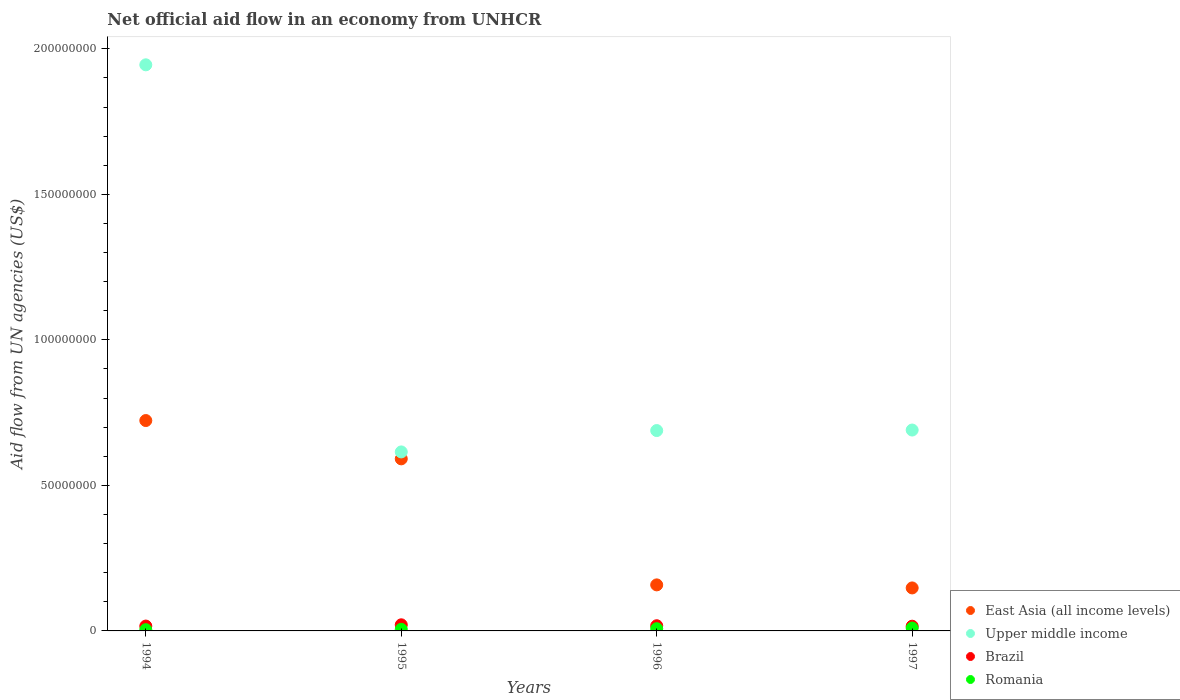Is the number of dotlines equal to the number of legend labels?
Your response must be concise. Yes. What is the net official aid flow in Brazil in 1997?
Your response must be concise. 1.62e+06. Across all years, what is the maximum net official aid flow in Upper middle income?
Provide a succinct answer. 1.94e+08. Across all years, what is the minimum net official aid flow in Brazil?
Provide a succinct answer. 1.62e+06. What is the total net official aid flow in Brazil in the graph?
Provide a succinct answer. 7.17e+06. What is the difference between the net official aid flow in Brazil in 1995 and that in 1996?
Ensure brevity in your answer.  3.20e+05. What is the difference between the net official aid flow in Romania in 1997 and the net official aid flow in Brazil in 1996?
Make the answer very short. -7.90e+05. What is the average net official aid flow in Brazil per year?
Provide a short and direct response. 1.79e+06. In the year 1997, what is the difference between the net official aid flow in Brazil and net official aid flow in Upper middle income?
Make the answer very short. -6.74e+07. In how many years, is the net official aid flow in Upper middle income greater than 140000000 US$?
Make the answer very short. 1. What is the ratio of the net official aid flow in Brazil in 1994 to that in 1996?
Provide a succinct answer. 0.94. What is the difference between the highest and the second highest net official aid flow in Romania?
Give a very brief answer. 2.30e+05. What is the difference between the highest and the lowest net official aid flow in Romania?
Your answer should be compact. 5.60e+05. Is it the case that in every year, the sum of the net official aid flow in Brazil and net official aid flow in Upper middle income  is greater than the sum of net official aid flow in East Asia (all income levels) and net official aid flow in Romania?
Provide a short and direct response. No. Is it the case that in every year, the sum of the net official aid flow in Brazil and net official aid flow in Romania  is greater than the net official aid flow in Upper middle income?
Provide a succinct answer. No. Is the net official aid flow in East Asia (all income levels) strictly less than the net official aid flow in Upper middle income over the years?
Ensure brevity in your answer.  Yes. How many years are there in the graph?
Your answer should be compact. 4. What is the difference between two consecutive major ticks on the Y-axis?
Provide a succinct answer. 5.00e+07. How many legend labels are there?
Offer a very short reply. 4. What is the title of the graph?
Provide a succinct answer. Net official aid flow in an economy from UNHCR. What is the label or title of the X-axis?
Keep it short and to the point. Years. What is the label or title of the Y-axis?
Provide a short and direct response. Aid flow from UN agencies (US$). What is the Aid flow from UN agencies (US$) of East Asia (all income levels) in 1994?
Ensure brevity in your answer.  7.23e+07. What is the Aid flow from UN agencies (US$) in Upper middle income in 1994?
Ensure brevity in your answer.  1.94e+08. What is the Aid flow from UN agencies (US$) in Brazil in 1994?
Provide a succinct answer. 1.67e+06. What is the Aid flow from UN agencies (US$) of East Asia (all income levels) in 1995?
Ensure brevity in your answer.  5.91e+07. What is the Aid flow from UN agencies (US$) of Upper middle income in 1995?
Offer a very short reply. 6.15e+07. What is the Aid flow from UN agencies (US$) of Brazil in 1995?
Give a very brief answer. 2.10e+06. What is the Aid flow from UN agencies (US$) of Romania in 1995?
Offer a very short reply. 5.50e+05. What is the Aid flow from UN agencies (US$) in East Asia (all income levels) in 1996?
Offer a very short reply. 1.58e+07. What is the Aid flow from UN agencies (US$) of Upper middle income in 1996?
Ensure brevity in your answer.  6.88e+07. What is the Aid flow from UN agencies (US$) of Brazil in 1996?
Your response must be concise. 1.78e+06. What is the Aid flow from UN agencies (US$) of Romania in 1996?
Your answer should be compact. 7.60e+05. What is the Aid flow from UN agencies (US$) in East Asia (all income levels) in 1997?
Give a very brief answer. 1.48e+07. What is the Aid flow from UN agencies (US$) of Upper middle income in 1997?
Provide a short and direct response. 6.90e+07. What is the Aid flow from UN agencies (US$) of Brazil in 1997?
Your response must be concise. 1.62e+06. What is the Aid flow from UN agencies (US$) of Romania in 1997?
Provide a short and direct response. 9.90e+05. Across all years, what is the maximum Aid flow from UN agencies (US$) in East Asia (all income levels)?
Your answer should be compact. 7.23e+07. Across all years, what is the maximum Aid flow from UN agencies (US$) in Upper middle income?
Provide a succinct answer. 1.94e+08. Across all years, what is the maximum Aid flow from UN agencies (US$) of Brazil?
Your answer should be very brief. 2.10e+06. Across all years, what is the maximum Aid flow from UN agencies (US$) in Romania?
Provide a short and direct response. 9.90e+05. Across all years, what is the minimum Aid flow from UN agencies (US$) in East Asia (all income levels)?
Make the answer very short. 1.48e+07. Across all years, what is the minimum Aid flow from UN agencies (US$) of Upper middle income?
Provide a short and direct response. 6.15e+07. Across all years, what is the minimum Aid flow from UN agencies (US$) in Brazil?
Offer a very short reply. 1.62e+06. What is the total Aid flow from UN agencies (US$) of East Asia (all income levels) in the graph?
Your answer should be compact. 1.62e+08. What is the total Aid flow from UN agencies (US$) in Upper middle income in the graph?
Make the answer very short. 3.94e+08. What is the total Aid flow from UN agencies (US$) in Brazil in the graph?
Your response must be concise. 7.17e+06. What is the total Aid flow from UN agencies (US$) in Romania in the graph?
Your response must be concise. 2.73e+06. What is the difference between the Aid flow from UN agencies (US$) of East Asia (all income levels) in 1994 and that in 1995?
Offer a very short reply. 1.32e+07. What is the difference between the Aid flow from UN agencies (US$) in Upper middle income in 1994 and that in 1995?
Your answer should be very brief. 1.33e+08. What is the difference between the Aid flow from UN agencies (US$) in Brazil in 1994 and that in 1995?
Provide a succinct answer. -4.30e+05. What is the difference between the Aid flow from UN agencies (US$) in Romania in 1994 and that in 1995?
Provide a succinct answer. -1.20e+05. What is the difference between the Aid flow from UN agencies (US$) in East Asia (all income levels) in 1994 and that in 1996?
Give a very brief answer. 5.65e+07. What is the difference between the Aid flow from UN agencies (US$) in Upper middle income in 1994 and that in 1996?
Make the answer very short. 1.26e+08. What is the difference between the Aid flow from UN agencies (US$) of Romania in 1994 and that in 1996?
Make the answer very short. -3.30e+05. What is the difference between the Aid flow from UN agencies (US$) in East Asia (all income levels) in 1994 and that in 1997?
Ensure brevity in your answer.  5.75e+07. What is the difference between the Aid flow from UN agencies (US$) in Upper middle income in 1994 and that in 1997?
Your answer should be compact. 1.25e+08. What is the difference between the Aid flow from UN agencies (US$) of Brazil in 1994 and that in 1997?
Offer a very short reply. 5.00e+04. What is the difference between the Aid flow from UN agencies (US$) of Romania in 1994 and that in 1997?
Offer a terse response. -5.60e+05. What is the difference between the Aid flow from UN agencies (US$) of East Asia (all income levels) in 1995 and that in 1996?
Your answer should be compact. 4.33e+07. What is the difference between the Aid flow from UN agencies (US$) in Upper middle income in 1995 and that in 1996?
Your answer should be very brief. -7.34e+06. What is the difference between the Aid flow from UN agencies (US$) in Brazil in 1995 and that in 1996?
Provide a succinct answer. 3.20e+05. What is the difference between the Aid flow from UN agencies (US$) in Romania in 1995 and that in 1996?
Give a very brief answer. -2.10e+05. What is the difference between the Aid flow from UN agencies (US$) of East Asia (all income levels) in 1995 and that in 1997?
Ensure brevity in your answer.  4.44e+07. What is the difference between the Aid flow from UN agencies (US$) of Upper middle income in 1995 and that in 1997?
Ensure brevity in your answer.  -7.52e+06. What is the difference between the Aid flow from UN agencies (US$) in Brazil in 1995 and that in 1997?
Make the answer very short. 4.80e+05. What is the difference between the Aid flow from UN agencies (US$) in Romania in 1995 and that in 1997?
Your answer should be compact. -4.40e+05. What is the difference between the Aid flow from UN agencies (US$) of East Asia (all income levels) in 1996 and that in 1997?
Provide a short and direct response. 1.05e+06. What is the difference between the Aid flow from UN agencies (US$) in Romania in 1996 and that in 1997?
Offer a terse response. -2.30e+05. What is the difference between the Aid flow from UN agencies (US$) of East Asia (all income levels) in 1994 and the Aid flow from UN agencies (US$) of Upper middle income in 1995?
Offer a very short reply. 1.08e+07. What is the difference between the Aid flow from UN agencies (US$) of East Asia (all income levels) in 1994 and the Aid flow from UN agencies (US$) of Brazil in 1995?
Make the answer very short. 7.02e+07. What is the difference between the Aid flow from UN agencies (US$) of East Asia (all income levels) in 1994 and the Aid flow from UN agencies (US$) of Romania in 1995?
Your answer should be very brief. 7.17e+07. What is the difference between the Aid flow from UN agencies (US$) of Upper middle income in 1994 and the Aid flow from UN agencies (US$) of Brazil in 1995?
Offer a terse response. 1.92e+08. What is the difference between the Aid flow from UN agencies (US$) of Upper middle income in 1994 and the Aid flow from UN agencies (US$) of Romania in 1995?
Make the answer very short. 1.94e+08. What is the difference between the Aid flow from UN agencies (US$) of Brazil in 1994 and the Aid flow from UN agencies (US$) of Romania in 1995?
Your answer should be compact. 1.12e+06. What is the difference between the Aid flow from UN agencies (US$) of East Asia (all income levels) in 1994 and the Aid flow from UN agencies (US$) of Upper middle income in 1996?
Your answer should be very brief. 3.44e+06. What is the difference between the Aid flow from UN agencies (US$) in East Asia (all income levels) in 1994 and the Aid flow from UN agencies (US$) in Brazil in 1996?
Give a very brief answer. 7.05e+07. What is the difference between the Aid flow from UN agencies (US$) in East Asia (all income levels) in 1994 and the Aid flow from UN agencies (US$) in Romania in 1996?
Your answer should be very brief. 7.15e+07. What is the difference between the Aid flow from UN agencies (US$) in Upper middle income in 1994 and the Aid flow from UN agencies (US$) in Brazil in 1996?
Ensure brevity in your answer.  1.93e+08. What is the difference between the Aid flow from UN agencies (US$) in Upper middle income in 1994 and the Aid flow from UN agencies (US$) in Romania in 1996?
Offer a terse response. 1.94e+08. What is the difference between the Aid flow from UN agencies (US$) in Brazil in 1994 and the Aid flow from UN agencies (US$) in Romania in 1996?
Your answer should be compact. 9.10e+05. What is the difference between the Aid flow from UN agencies (US$) in East Asia (all income levels) in 1994 and the Aid flow from UN agencies (US$) in Upper middle income in 1997?
Give a very brief answer. 3.26e+06. What is the difference between the Aid flow from UN agencies (US$) in East Asia (all income levels) in 1994 and the Aid flow from UN agencies (US$) in Brazil in 1997?
Offer a very short reply. 7.07e+07. What is the difference between the Aid flow from UN agencies (US$) of East Asia (all income levels) in 1994 and the Aid flow from UN agencies (US$) of Romania in 1997?
Make the answer very short. 7.13e+07. What is the difference between the Aid flow from UN agencies (US$) in Upper middle income in 1994 and the Aid flow from UN agencies (US$) in Brazil in 1997?
Give a very brief answer. 1.93e+08. What is the difference between the Aid flow from UN agencies (US$) of Upper middle income in 1994 and the Aid flow from UN agencies (US$) of Romania in 1997?
Provide a short and direct response. 1.94e+08. What is the difference between the Aid flow from UN agencies (US$) in Brazil in 1994 and the Aid flow from UN agencies (US$) in Romania in 1997?
Provide a short and direct response. 6.80e+05. What is the difference between the Aid flow from UN agencies (US$) of East Asia (all income levels) in 1995 and the Aid flow from UN agencies (US$) of Upper middle income in 1996?
Keep it short and to the point. -9.72e+06. What is the difference between the Aid flow from UN agencies (US$) in East Asia (all income levels) in 1995 and the Aid flow from UN agencies (US$) in Brazil in 1996?
Ensure brevity in your answer.  5.73e+07. What is the difference between the Aid flow from UN agencies (US$) in East Asia (all income levels) in 1995 and the Aid flow from UN agencies (US$) in Romania in 1996?
Offer a terse response. 5.84e+07. What is the difference between the Aid flow from UN agencies (US$) in Upper middle income in 1995 and the Aid flow from UN agencies (US$) in Brazil in 1996?
Make the answer very short. 5.97e+07. What is the difference between the Aid flow from UN agencies (US$) in Upper middle income in 1995 and the Aid flow from UN agencies (US$) in Romania in 1996?
Make the answer very short. 6.07e+07. What is the difference between the Aid flow from UN agencies (US$) in Brazil in 1995 and the Aid flow from UN agencies (US$) in Romania in 1996?
Offer a terse response. 1.34e+06. What is the difference between the Aid flow from UN agencies (US$) in East Asia (all income levels) in 1995 and the Aid flow from UN agencies (US$) in Upper middle income in 1997?
Make the answer very short. -9.90e+06. What is the difference between the Aid flow from UN agencies (US$) in East Asia (all income levels) in 1995 and the Aid flow from UN agencies (US$) in Brazil in 1997?
Your answer should be very brief. 5.75e+07. What is the difference between the Aid flow from UN agencies (US$) of East Asia (all income levels) in 1995 and the Aid flow from UN agencies (US$) of Romania in 1997?
Your response must be concise. 5.81e+07. What is the difference between the Aid flow from UN agencies (US$) in Upper middle income in 1995 and the Aid flow from UN agencies (US$) in Brazil in 1997?
Offer a very short reply. 5.99e+07. What is the difference between the Aid flow from UN agencies (US$) in Upper middle income in 1995 and the Aid flow from UN agencies (US$) in Romania in 1997?
Offer a terse response. 6.05e+07. What is the difference between the Aid flow from UN agencies (US$) in Brazil in 1995 and the Aid flow from UN agencies (US$) in Romania in 1997?
Provide a short and direct response. 1.11e+06. What is the difference between the Aid flow from UN agencies (US$) of East Asia (all income levels) in 1996 and the Aid flow from UN agencies (US$) of Upper middle income in 1997?
Your response must be concise. -5.32e+07. What is the difference between the Aid flow from UN agencies (US$) in East Asia (all income levels) in 1996 and the Aid flow from UN agencies (US$) in Brazil in 1997?
Provide a succinct answer. 1.42e+07. What is the difference between the Aid flow from UN agencies (US$) in East Asia (all income levels) in 1996 and the Aid flow from UN agencies (US$) in Romania in 1997?
Provide a short and direct response. 1.48e+07. What is the difference between the Aid flow from UN agencies (US$) of Upper middle income in 1996 and the Aid flow from UN agencies (US$) of Brazil in 1997?
Ensure brevity in your answer.  6.72e+07. What is the difference between the Aid flow from UN agencies (US$) in Upper middle income in 1996 and the Aid flow from UN agencies (US$) in Romania in 1997?
Make the answer very short. 6.78e+07. What is the difference between the Aid flow from UN agencies (US$) in Brazil in 1996 and the Aid flow from UN agencies (US$) in Romania in 1997?
Your answer should be compact. 7.90e+05. What is the average Aid flow from UN agencies (US$) in East Asia (all income levels) per year?
Make the answer very short. 4.05e+07. What is the average Aid flow from UN agencies (US$) of Upper middle income per year?
Ensure brevity in your answer.  9.85e+07. What is the average Aid flow from UN agencies (US$) of Brazil per year?
Give a very brief answer. 1.79e+06. What is the average Aid flow from UN agencies (US$) in Romania per year?
Offer a terse response. 6.82e+05. In the year 1994, what is the difference between the Aid flow from UN agencies (US$) in East Asia (all income levels) and Aid flow from UN agencies (US$) in Upper middle income?
Your answer should be compact. -1.22e+08. In the year 1994, what is the difference between the Aid flow from UN agencies (US$) in East Asia (all income levels) and Aid flow from UN agencies (US$) in Brazil?
Give a very brief answer. 7.06e+07. In the year 1994, what is the difference between the Aid flow from UN agencies (US$) of East Asia (all income levels) and Aid flow from UN agencies (US$) of Romania?
Give a very brief answer. 7.18e+07. In the year 1994, what is the difference between the Aid flow from UN agencies (US$) of Upper middle income and Aid flow from UN agencies (US$) of Brazil?
Your answer should be compact. 1.93e+08. In the year 1994, what is the difference between the Aid flow from UN agencies (US$) in Upper middle income and Aid flow from UN agencies (US$) in Romania?
Your answer should be very brief. 1.94e+08. In the year 1994, what is the difference between the Aid flow from UN agencies (US$) of Brazil and Aid flow from UN agencies (US$) of Romania?
Give a very brief answer. 1.24e+06. In the year 1995, what is the difference between the Aid flow from UN agencies (US$) in East Asia (all income levels) and Aid flow from UN agencies (US$) in Upper middle income?
Offer a terse response. -2.38e+06. In the year 1995, what is the difference between the Aid flow from UN agencies (US$) in East Asia (all income levels) and Aid flow from UN agencies (US$) in Brazil?
Make the answer very short. 5.70e+07. In the year 1995, what is the difference between the Aid flow from UN agencies (US$) in East Asia (all income levels) and Aid flow from UN agencies (US$) in Romania?
Keep it short and to the point. 5.86e+07. In the year 1995, what is the difference between the Aid flow from UN agencies (US$) in Upper middle income and Aid flow from UN agencies (US$) in Brazil?
Ensure brevity in your answer.  5.94e+07. In the year 1995, what is the difference between the Aid flow from UN agencies (US$) of Upper middle income and Aid flow from UN agencies (US$) of Romania?
Your answer should be compact. 6.10e+07. In the year 1995, what is the difference between the Aid flow from UN agencies (US$) of Brazil and Aid flow from UN agencies (US$) of Romania?
Offer a terse response. 1.55e+06. In the year 1996, what is the difference between the Aid flow from UN agencies (US$) of East Asia (all income levels) and Aid flow from UN agencies (US$) of Upper middle income?
Give a very brief answer. -5.30e+07. In the year 1996, what is the difference between the Aid flow from UN agencies (US$) in East Asia (all income levels) and Aid flow from UN agencies (US$) in Brazil?
Your answer should be very brief. 1.40e+07. In the year 1996, what is the difference between the Aid flow from UN agencies (US$) in East Asia (all income levels) and Aid flow from UN agencies (US$) in Romania?
Keep it short and to the point. 1.51e+07. In the year 1996, what is the difference between the Aid flow from UN agencies (US$) of Upper middle income and Aid flow from UN agencies (US$) of Brazil?
Your answer should be compact. 6.71e+07. In the year 1996, what is the difference between the Aid flow from UN agencies (US$) of Upper middle income and Aid flow from UN agencies (US$) of Romania?
Your response must be concise. 6.81e+07. In the year 1996, what is the difference between the Aid flow from UN agencies (US$) of Brazil and Aid flow from UN agencies (US$) of Romania?
Ensure brevity in your answer.  1.02e+06. In the year 1997, what is the difference between the Aid flow from UN agencies (US$) of East Asia (all income levels) and Aid flow from UN agencies (US$) of Upper middle income?
Provide a succinct answer. -5.42e+07. In the year 1997, what is the difference between the Aid flow from UN agencies (US$) in East Asia (all income levels) and Aid flow from UN agencies (US$) in Brazil?
Provide a short and direct response. 1.32e+07. In the year 1997, what is the difference between the Aid flow from UN agencies (US$) in East Asia (all income levels) and Aid flow from UN agencies (US$) in Romania?
Provide a succinct answer. 1.38e+07. In the year 1997, what is the difference between the Aid flow from UN agencies (US$) in Upper middle income and Aid flow from UN agencies (US$) in Brazil?
Your answer should be very brief. 6.74e+07. In the year 1997, what is the difference between the Aid flow from UN agencies (US$) of Upper middle income and Aid flow from UN agencies (US$) of Romania?
Offer a very short reply. 6.80e+07. In the year 1997, what is the difference between the Aid flow from UN agencies (US$) in Brazil and Aid flow from UN agencies (US$) in Romania?
Provide a succinct answer. 6.30e+05. What is the ratio of the Aid flow from UN agencies (US$) of East Asia (all income levels) in 1994 to that in 1995?
Your response must be concise. 1.22. What is the ratio of the Aid flow from UN agencies (US$) of Upper middle income in 1994 to that in 1995?
Keep it short and to the point. 3.16. What is the ratio of the Aid flow from UN agencies (US$) in Brazil in 1994 to that in 1995?
Offer a terse response. 0.8. What is the ratio of the Aid flow from UN agencies (US$) in Romania in 1994 to that in 1995?
Give a very brief answer. 0.78. What is the ratio of the Aid flow from UN agencies (US$) of East Asia (all income levels) in 1994 to that in 1996?
Make the answer very short. 4.57. What is the ratio of the Aid flow from UN agencies (US$) in Upper middle income in 1994 to that in 1996?
Make the answer very short. 2.83. What is the ratio of the Aid flow from UN agencies (US$) in Brazil in 1994 to that in 1996?
Provide a short and direct response. 0.94. What is the ratio of the Aid flow from UN agencies (US$) of Romania in 1994 to that in 1996?
Ensure brevity in your answer.  0.57. What is the ratio of the Aid flow from UN agencies (US$) of East Asia (all income levels) in 1994 to that in 1997?
Your response must be concise. 4.89. What is the ratio of the Aid flow from UN agencies (US$) of Upper middle income in 1994 to that in 1997?
Make the answer very short. 2.82. What is the ratio of the Aid flow from UN agencies (US$) of Brazil in 1994 to that in 1997?
Provide a succinct answer. 1.03. What is the ratio of the Aid flow from UN agencies (US$) in Romania in 1994 to that in 1997?
Give a very brief answer. 0.43. What is the ratio of the Aid flow from UN agencies (US$) in East Asia (all income levels) in 1995 to that in 1996?
Keep it short and to the point. 3.74. What is the ratio of the Aid flow from UN agencies (US$) of Upper middle income in 1995 to that in 1996?
Your answer should be compact. 0.89. What is the ratio of the Aid flow from UN agencies (US$) in Brazil in 1995 to that in 1996?
Keep it short and to the point. 1.18. What is the ratio of the Aid flow from UN agencies (US$) in Romania in 1995 to that in 1996?
Give a very brief answer. 0.72. What is the ratio of the Aid flow from UN agencies (US$) of East Asia (all income levels) in 1995 to that in 1997?
Give a very brief answer. 4. What is the ratio of the Aid flow from UN agencies (US$) in Upper middle income in 1995 to that in 1997?
Keep it short and to the point. 0.89. What is the ratio of the Aid flow from UN agencies (US$) in Brazil in 1995 to that in 1997?
Offer a very short reply. 1.3. What is the ratio of the Aid flow from UN agencies (US$) in Romania in 1995 to that in 1997?
Offer a terse response. 0.56. What is the ratio of the Aid flow from UN agencies (US$) of East Asia (all income levels) in 1996 to that in 1997?
Make the answer very short. 1.07. What is the ratio of the Aid flow from UN agencies (US$) in Upper middle income in 1996 to that in 1997?
Your answer should be very brief. 1. What is the ratio of the Aid flow from UN agencies (US$) in Brazil in 1996 to that in 1997?
Provide a short and direct response. 1.1. What is the ratio of the Aid flow from UN agencies (US$) in Romania in 1996 to that in 1997?
Your answer should be compact. 0.77. What is the difference between the highest and the second highest Aid flow from UN agencies (US$) of East Asia (all income levels)?
Your response must be concise. 1.32e+07. What is the difference between the highest and the second highest Aid flow from UN agencies (US$) of Upper middle income?
Your answer should be very brief. 1.25e+08. What is the difference between the highest and the second highest Aid flow from UN agencies (US$) in Brazil?
Provide a succinct answer. 3.20e+05. What is the difference between the highest and the second highest Aid flow from UN agencies (US$) of Romania?
Offer a very short reply. 2.30e+05. What is the difference between the highest and the lowest Aid flow from UN agencies (US$) of East Asia (all income levels)?
Your response must be concise. 5.75e+07. What is the difference between the highest and the lowest Aid flow from UN agencies (US$) of Upper middle income?
Keep it short and to the point. 1.33e+08. What is the difference between the highest and the lowest Aid flow from UN agencies (US$) in Romania?
Keep it short and to the point. 5.60e+05. 